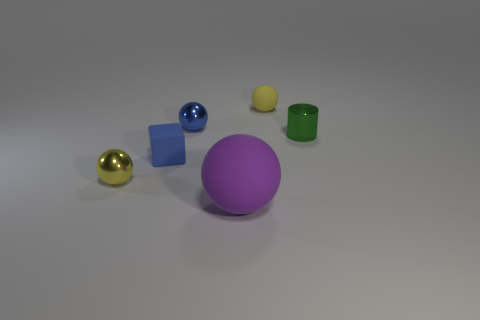How many yellow spheres must be subtracted to get 1 yellow spheres? 1 Subtract all small blue shiny spheres. How many spheres are left? 3 Subtract all purple spheres. How many spheres are left? 3 Subtract 3 balls. How many balls are left? 1 Add 3 yellow shiny objects. How many objects exist? 9 Subtract all red spheres. Subtract all yellow cylinders. How many spheres are left? 4 Subtract all gray balls. How many green blocks are left? 0 Subtract all blue cubes. Subtract all metallic cylinders. How many objects are left? 4 Add 1 small blue objects. How many small blue objects are left? 3 Add 4 big blue metal cylinders. How many big blue metal cylinders exist? 4 